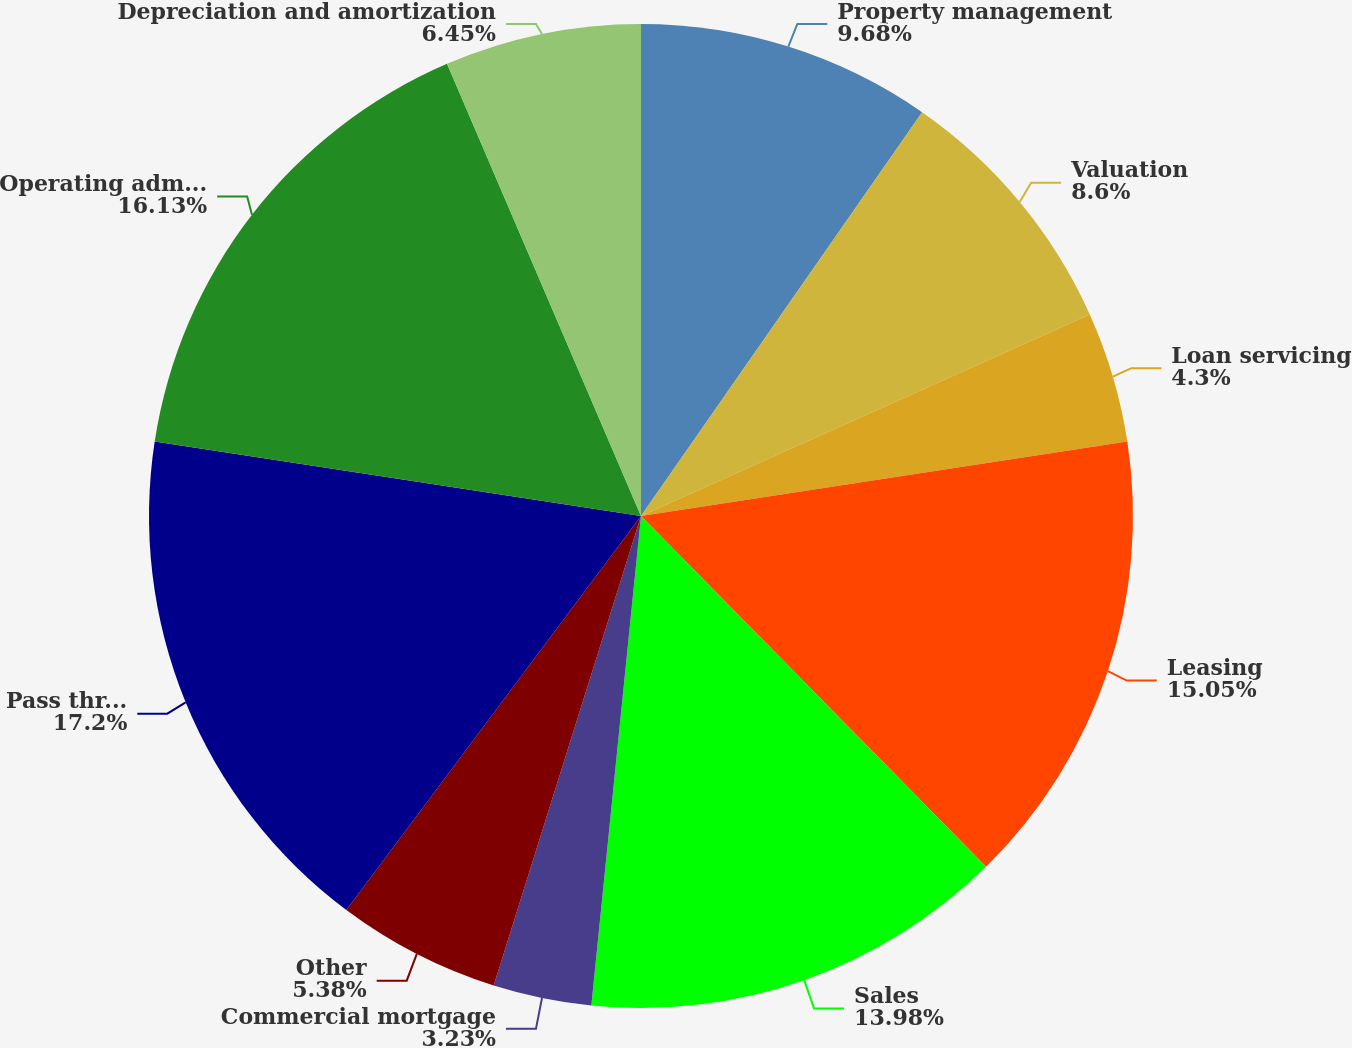<chart> <loc_0><loc_0><loc_500><loc_500><pie_chart><fcel>Property management<fcel>Valuation<fcel>Loan servicing<fcel>Leasing<fcel>Sales<fcel>Commercial mortgage<fcel>Other<fcel>Pass through costs also<fcel>Operating administrative and<fcel>Depreciation and amortization<nl><fcel>9.68%<fcel>8.6%<fcel>4.3%<fcel>15.05%<fcel>13.98%<fcel>3.23%<fcel>5.38%<fcel>17.2%<fcel>16.13%<fcel>6.45%<nl></chart> 